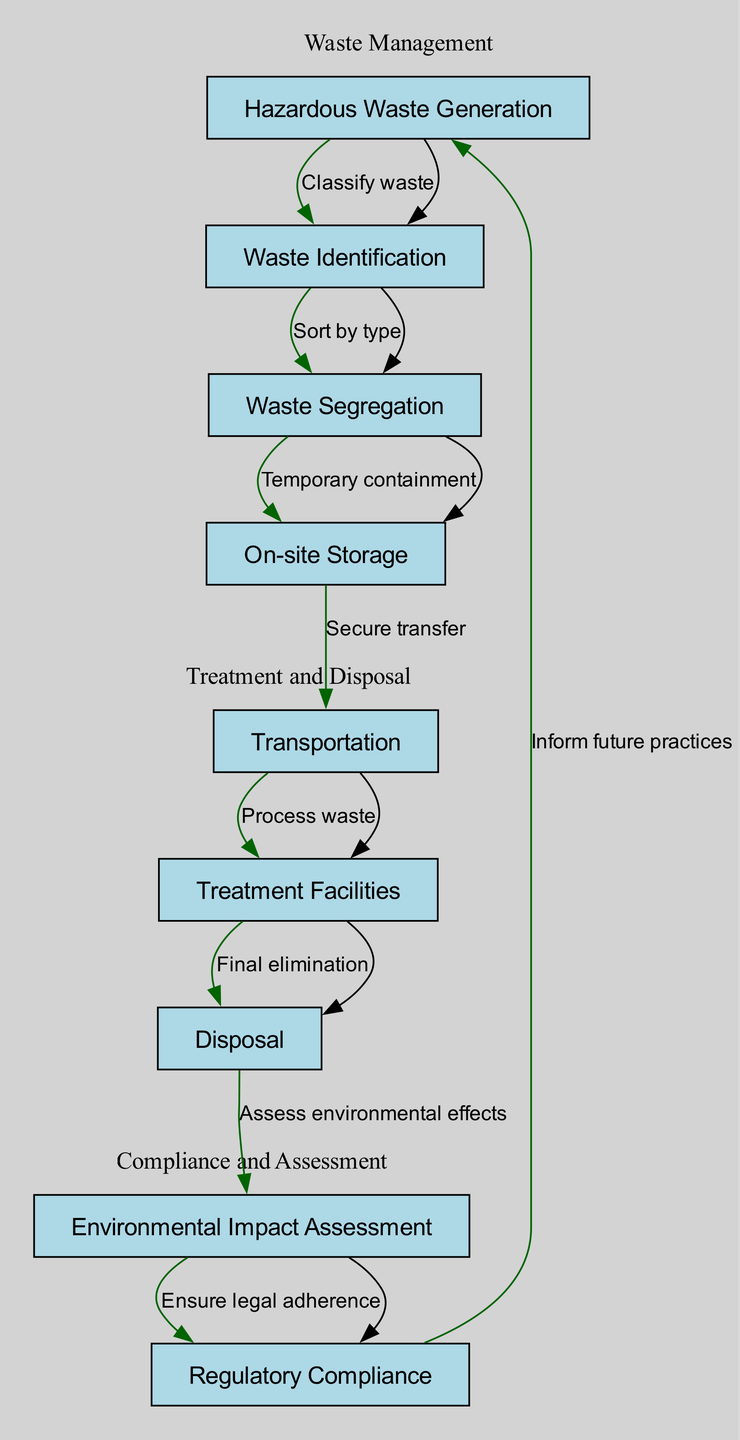What is the first step in hazardous waste management? The diagram starts with the node labeled "Hazardous Waste Generation," which represents the beginning of the lifecycle.
Answer: Hazardous Waste Generation How many total nodes are present in the diagram? By counting the nodes listed in the diagram, there are nine distinct nodes represented.
Answer: 9 What action is taken after waste identification? The diagram indicates that after "Waste Identification," the next step is "Waste Segregation," which is the process of sorting waste by type.
Answer: Waste Segregation Which node immediately precedes "Transportation"? According to the flow of the diagram, "On-site Storage" is directly before "Transportation," indicating the secure transfer of waste.
Answer: On-site Storage What is the last step in the waste management process? The final action in the process shown in the diagram is "Inform future practices," linking back to hazardous waste generation, indicating a feedback loop for improvements.
Answer: Inform future practices How does regulatory compliance relate to environmental impact assessment? The flow shows that "Assess environmental effects" leads into "Ensure legal adherence," indicating that compliance is contingent upon assessing environmental impacts.
Answer: Ensure legal adherence What is the purpose of waste segregation? Waste segregation is aimed at sorting waste by type, which ensures proper handling and management of hazardous materials.
Answer: Sort by type How many edges are present in the diagram? By counting the edges that connect the nodes in the diagram, there are eight edges that depict the relationships and flow between the different steps.
Answer: 8 What is the purpose of treatment facilities? Treatment facilities serve to process waste as indicated by the edge flowing from "Transportation" to "Treatment Facilities."
Answer: Process waste What action is required before final disposal of hazardous waste? The diagram specifies that waste must go through "Treatment Facilities" before it can proceed to "Disposal" for final elimination.
Answer: Final elimination 